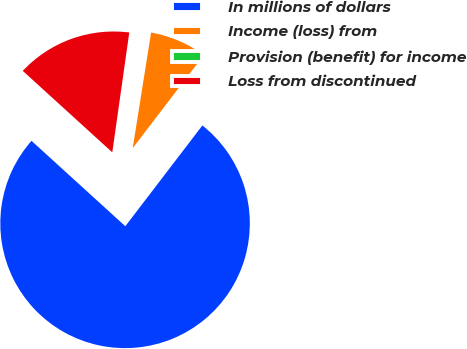<chart> <loc_0><loc_0><loc_500><loc_500><pie_chart><fcel>In millions of dollars<fcel>Income (loss) from<fcel>Provision (benefit) for income<fcel>Loss from discontinued<nl><fcel>76.37%<fcel>7.88%<fcel>0.27%<fcel>15.49%<nl></chart> 